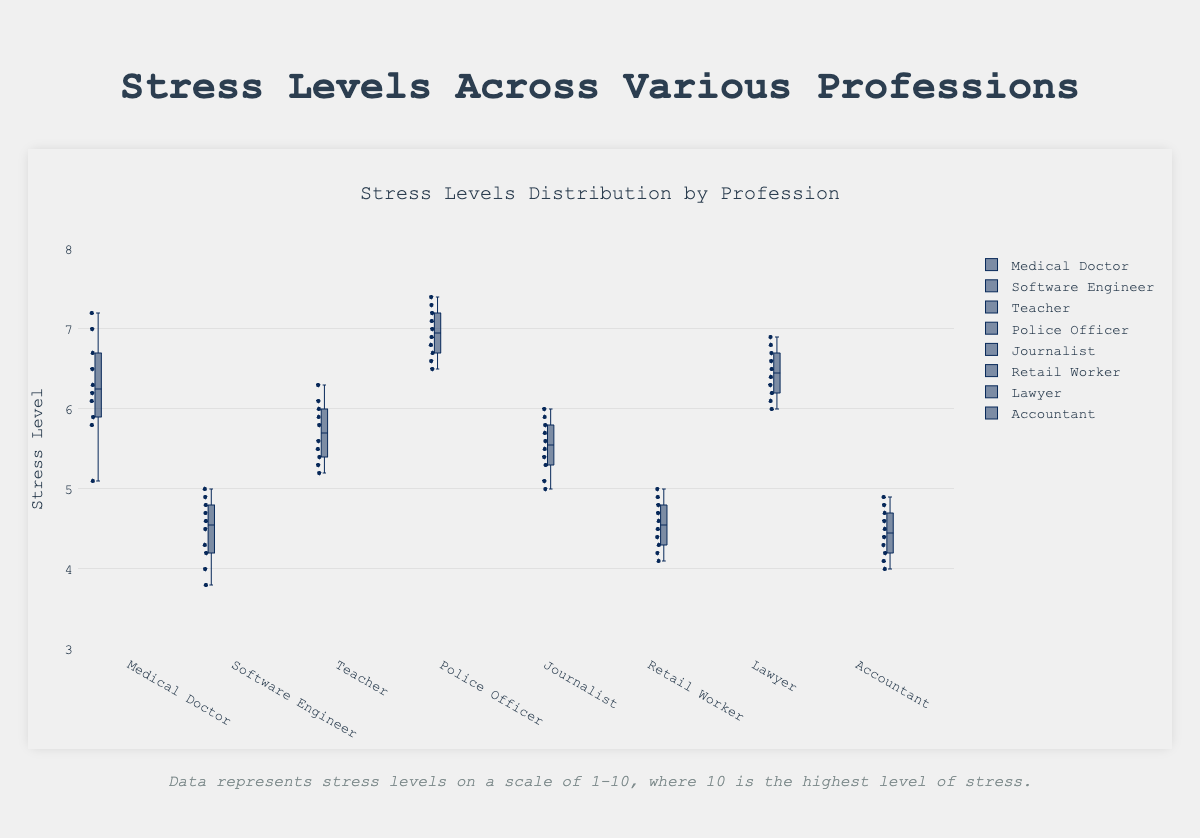What's the title of the plot? The title is displayed at the top of the chart.
Answer: Stress Levels Distribution by Profession What is the median stress level for Medical Doctors? To find the median, look at the line inside the Medical Doctor's box.
Answer: Around 6.3 Which profession has the highest maximum stress level? Identify the highest point for the whiskers (lines) extending above the boxes.
Answer: Police Officer What is the range of stress levels for Retail Workers? The range is the difference between the maximum and minimum values. For Retail Workers: max = 5.0, min = 4.1.
Answer: 0.9 Which profession has the smallest interquartile range (IQR)? The IQR is represented by the height of the box from Q1 to Q3. The smallest box visually is for Accountant.
Answer: Accountant How does the median stress level of Software Engineers compare to that of Lawyers? Compare the medians indicated by the lines inside the boxes for both professions.
Answer: Lower What is the stress level value at the first quartile (Q1) for Journalists? Q1 is the bottom of the box for Journalists.
Answer: Around 5.2 Which professions have outliers? Look for dots that are outside the whiskers (lines) extending from the box.
Answer: None Between Police Officers and Medical Doctors, who shows more variability in stress levels? Compare the total length (range) of the boxes and whiskers for both.
Answer: Police Officers What is the median difference in stress levels between Police Officers and Teachers? Calculate the difference between the medians: Police Officers (around 7.0), Teachers (around 5.8).
Answer: 1.2 